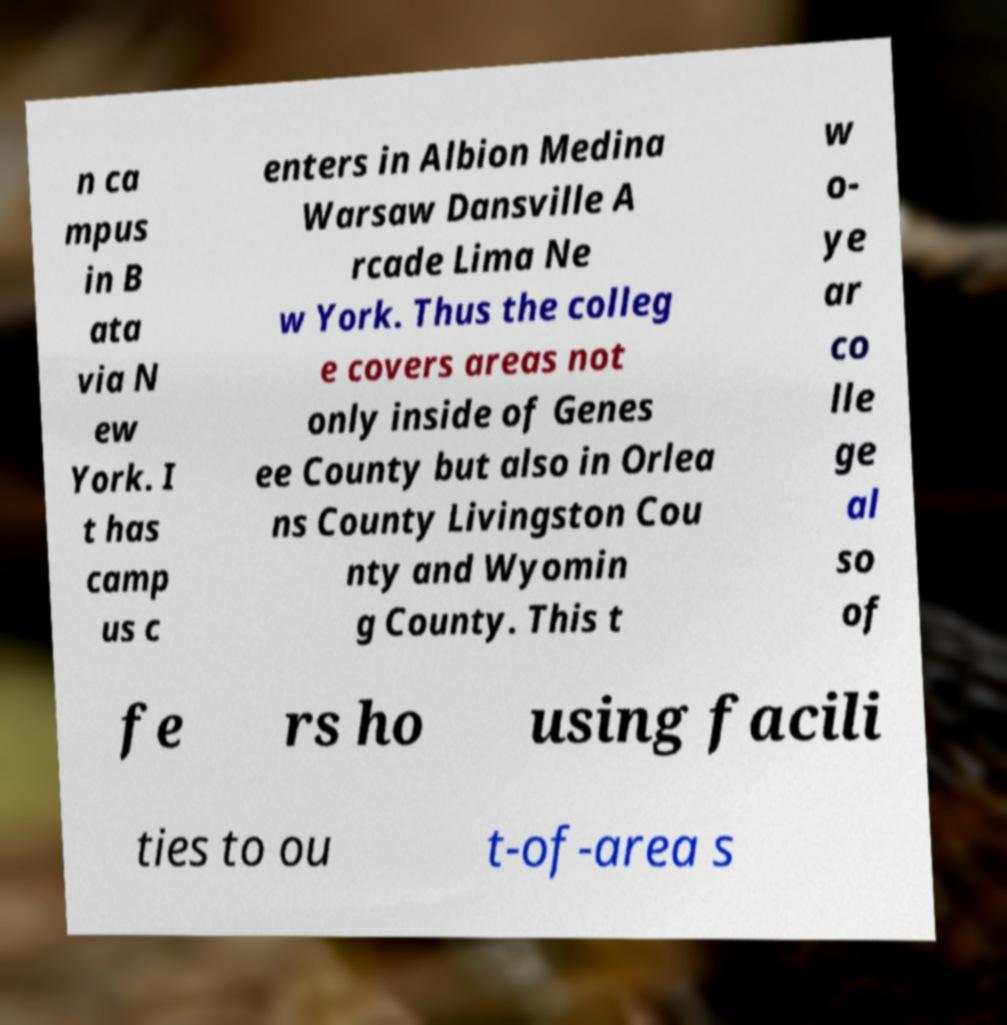There's text embedded in this image that I need extracted. Can you transcribe it verbatim? n ca mpus in B ata via N ew York. I t has camp us c enters in Albion Medina Warsaw Dansville A rcade Lima Ne w York. Thus the colleg e covers areas not only inside of Genes ee County but also in Orlea ns County Livingston Cou nty and Wyomin g County. This t w o- ye ar co lle ge al so of fe rs ho using facili ties to ou t-of-area s 